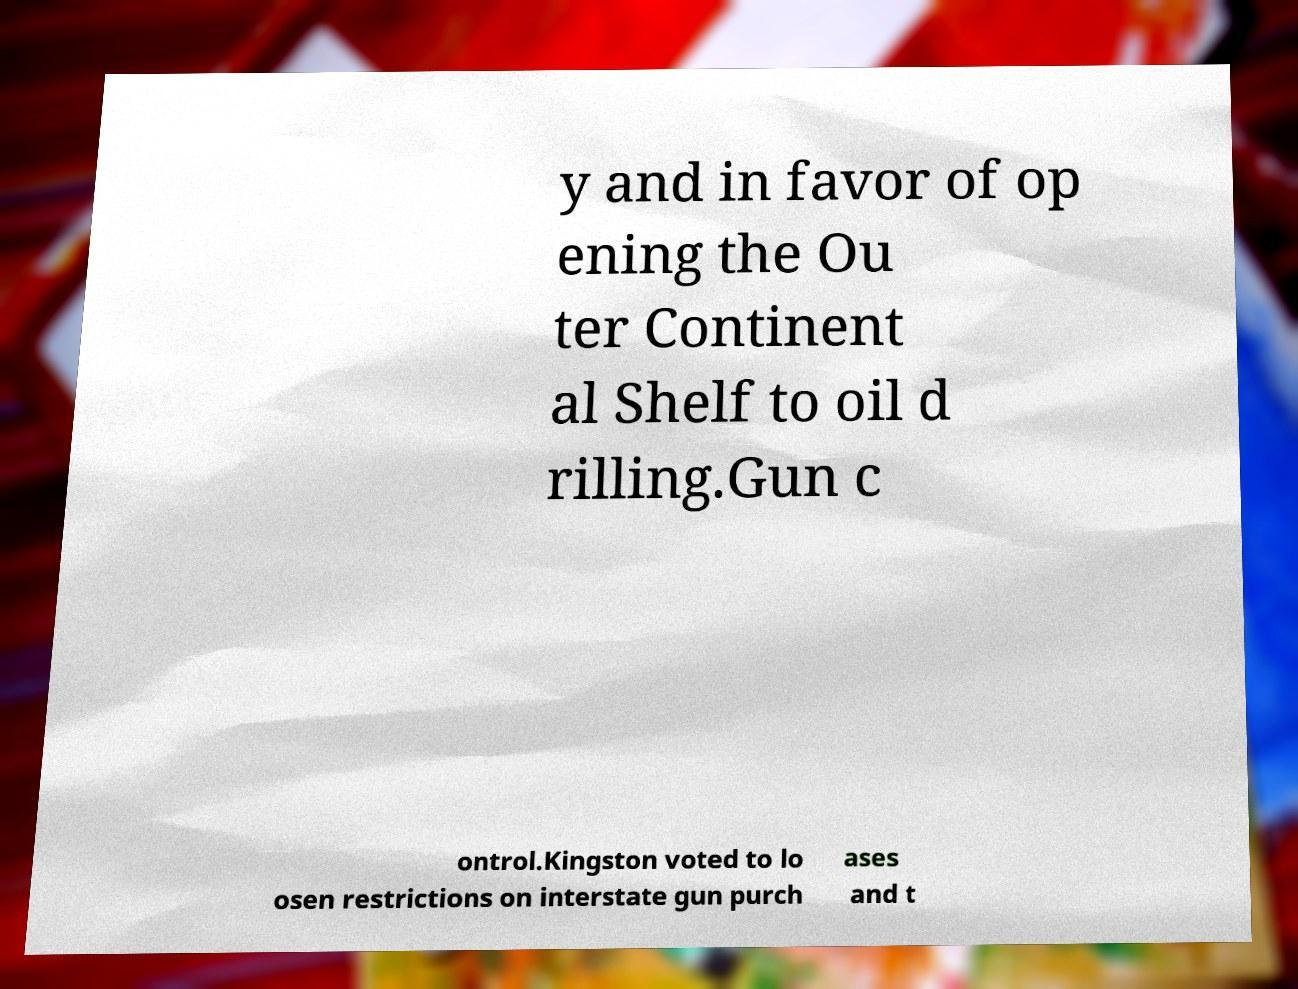Please identify and transcribe the text found in this image. y and in favor of op ening the Ou ter Continent al Shelf to oil d rilling.Gun c ontrol.Kingston voted to lo osen restrictions on interstate gun purch ases and t 